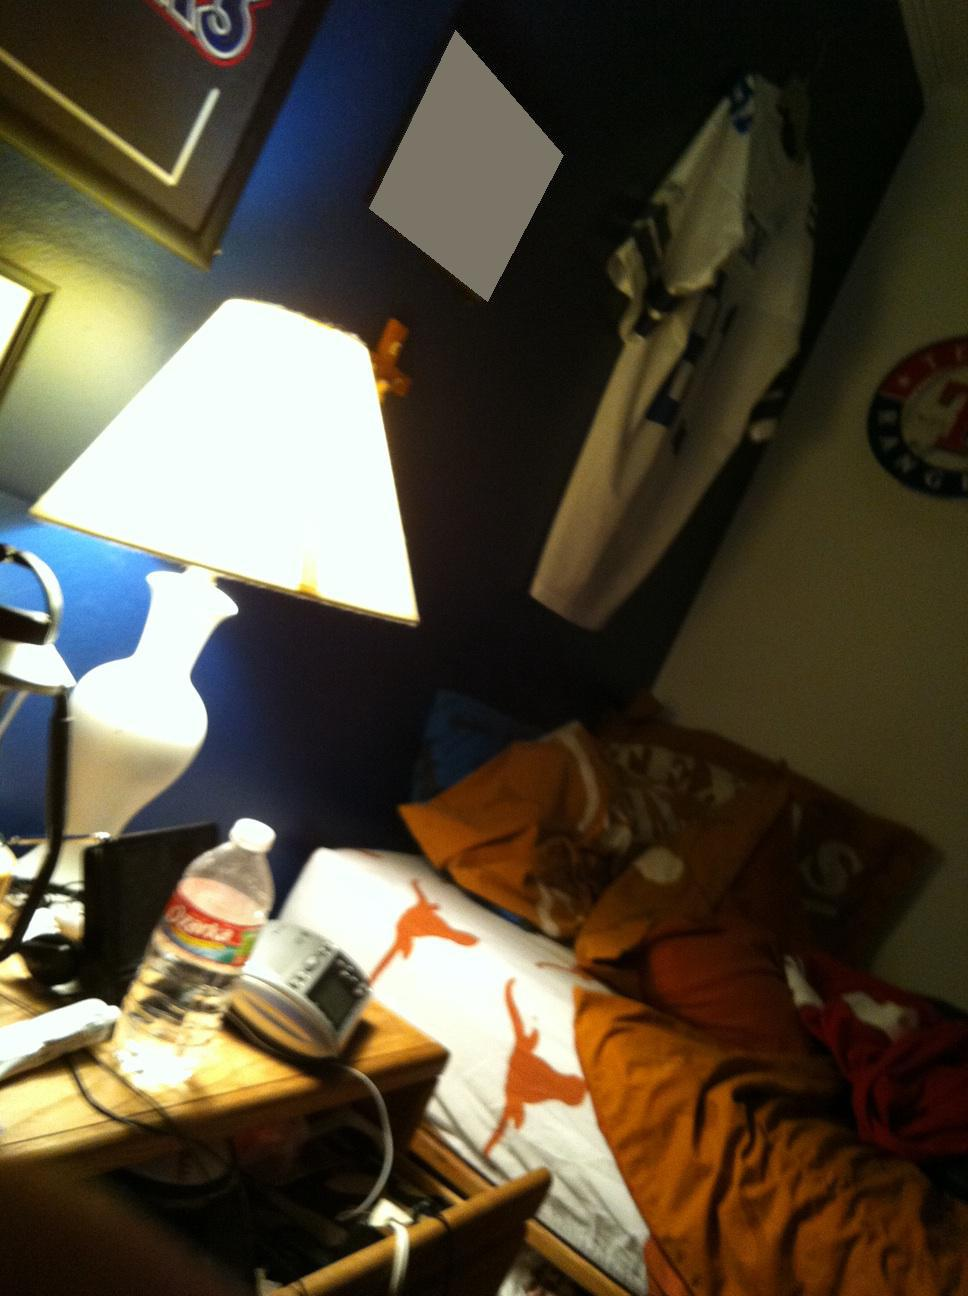Is my light off? from Vizwiz no 